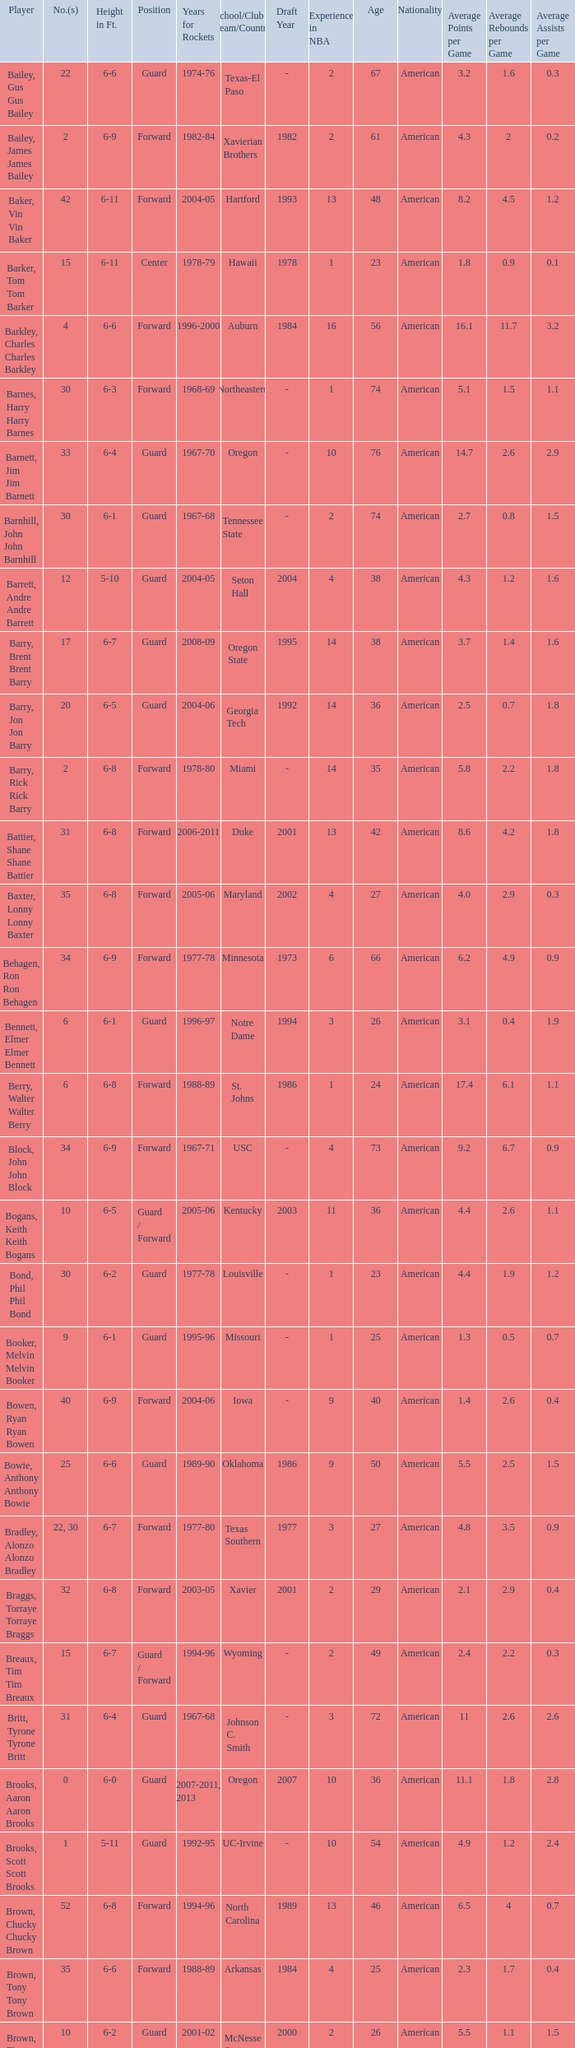What is the height of the player who attended Hartford? 6-11. 